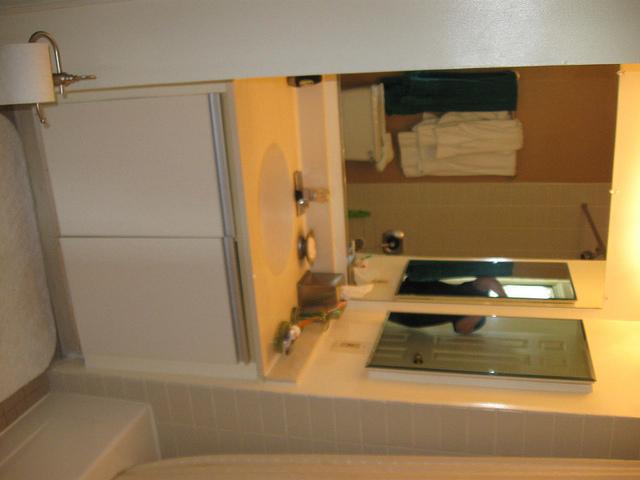How many mirrors are there?
Answer briefly. 2. Is there toilet paper in the photo?
Answer briefly. Yes. Where is the box of kleenex?
Give a very brief answer. On sink. 